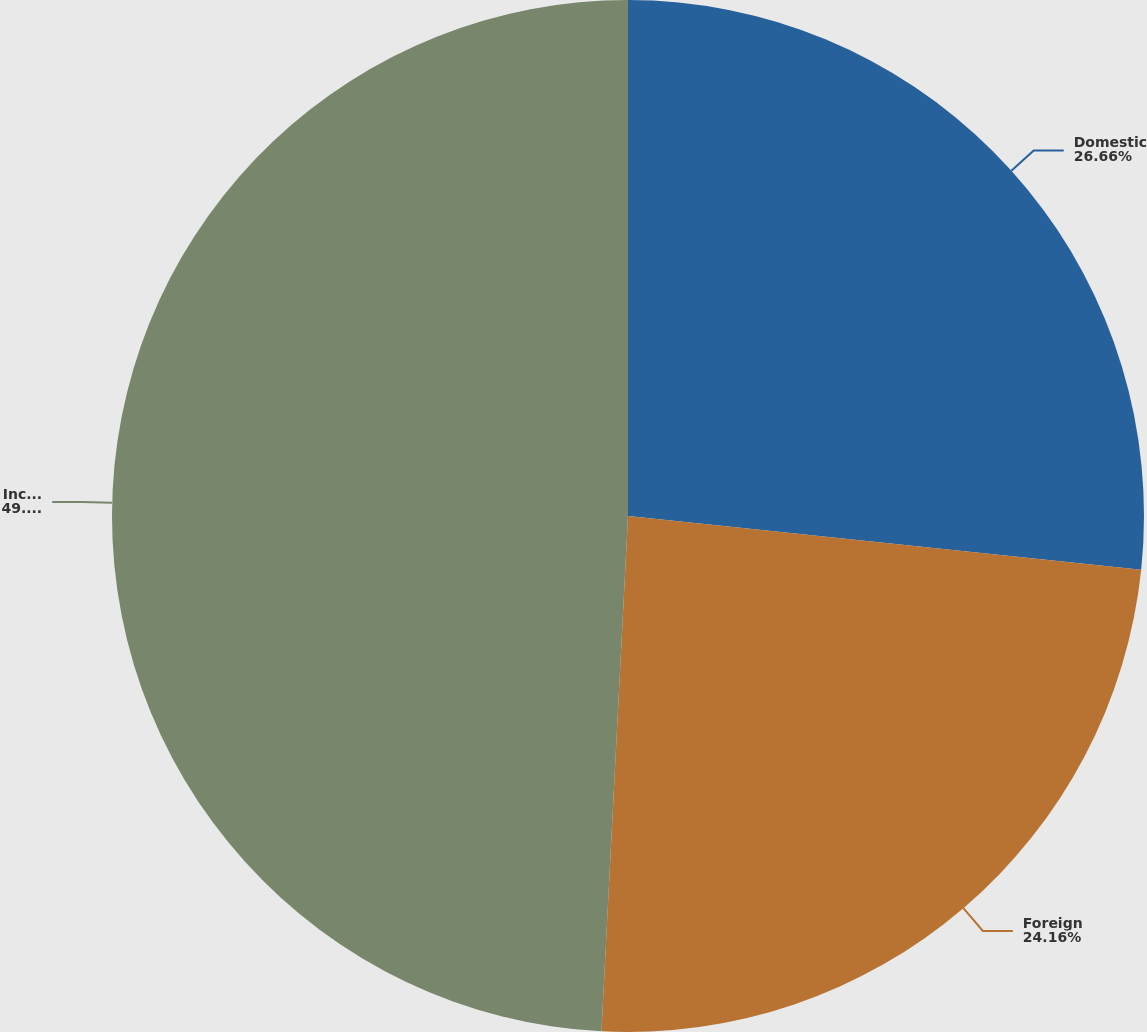Convert chart. <chart><loc_0><loc_0><loc_500><loc_500><pie_chart><fcel>Domestic<fcel>Foreign<fcel>Income before provision for<nl><fcel>26.66%<fcel>24.16%<fcel>49.18%<nl></chart> 